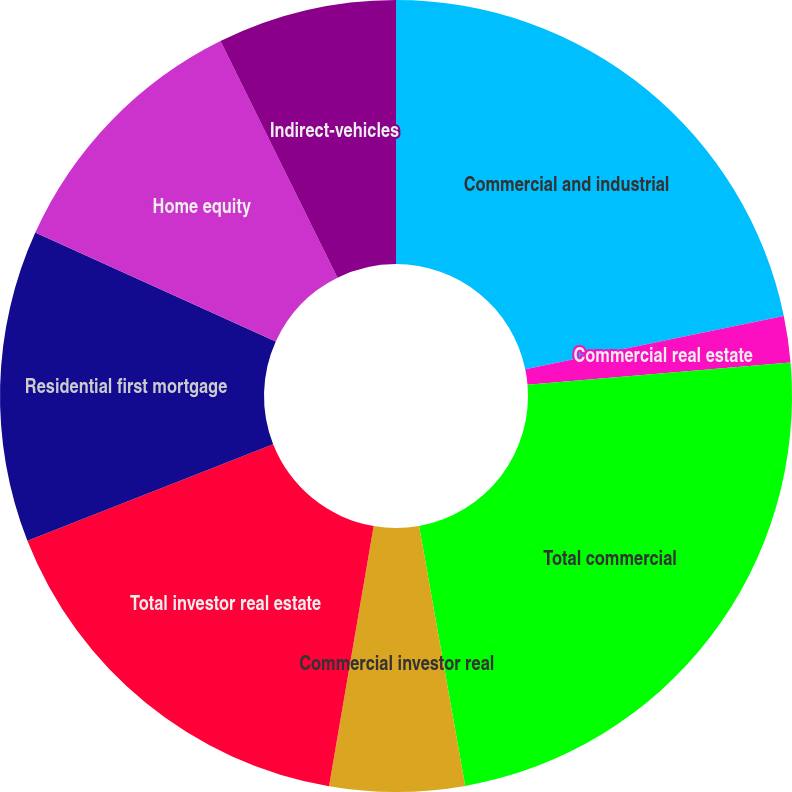<chart> <loc_0><loc_0><loc_500><loc_500><pie_chart><fcel>Commercial and industrial<fcel>Commercial real estate<fcel>Total commercial<fcel>Commercial investor real<fcel>Total investor real estate<fcel>Residential first mortgage<fcel>Home equity<fcel>Indirect-vehicles<nl><fcel>21.76%<fcel>1.89%<fcel>23.56%<fcel>5.5%<fcel>16.34%<fcel>12.73%<fcel>10.92%<fcel>7.31%<nl></chart> 